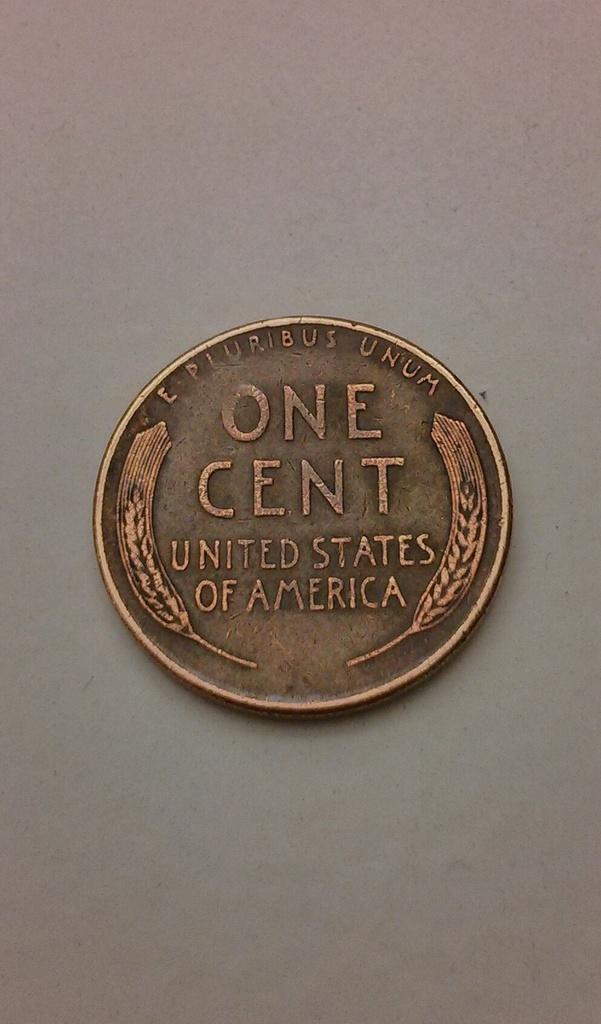Provide a one-sentence caption for the provided image. An old one cent coin from US currency. 